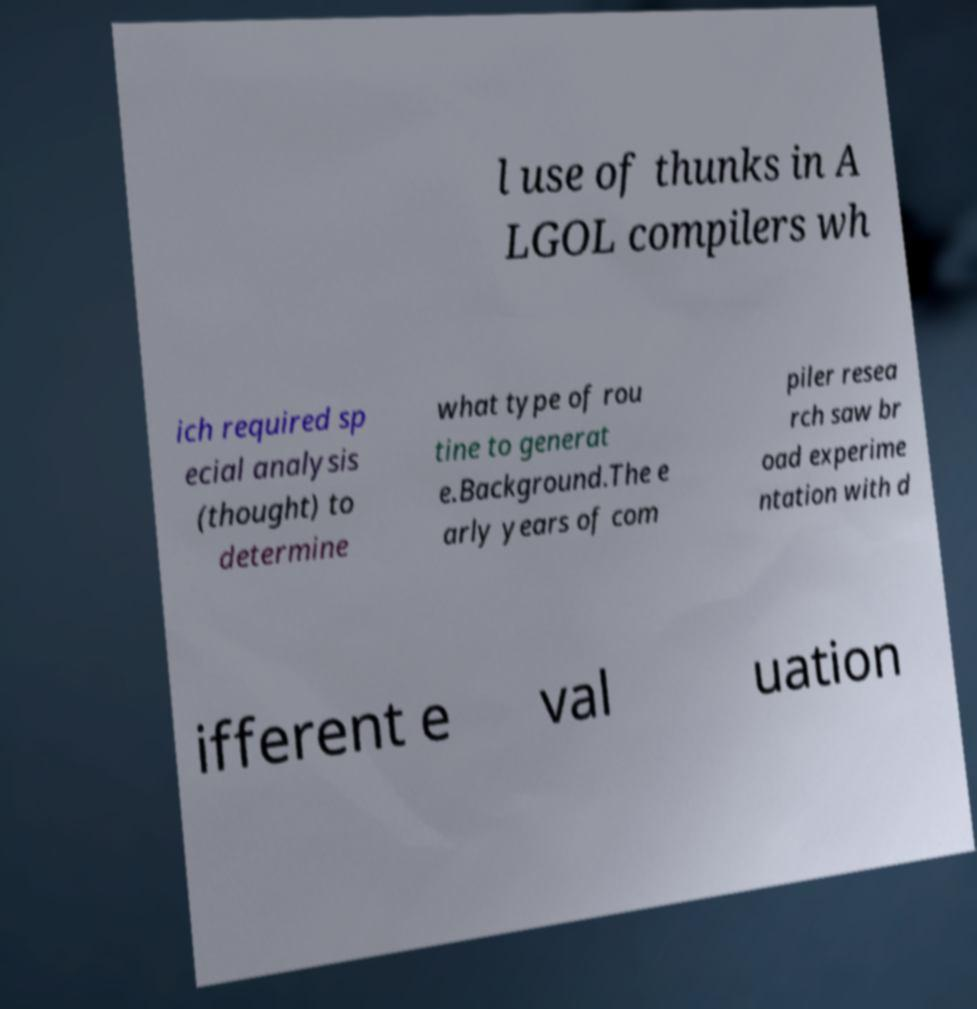Please read and relay the text visible in this image. What does it say? l use of thunks in A LGOL compilers wh ich required sp ecial analysis (thought) to determine what type of rou tine to generat e.Background.The e arly years of com piler resea rch saw br oad experime ntation with d ifferent e val uation 